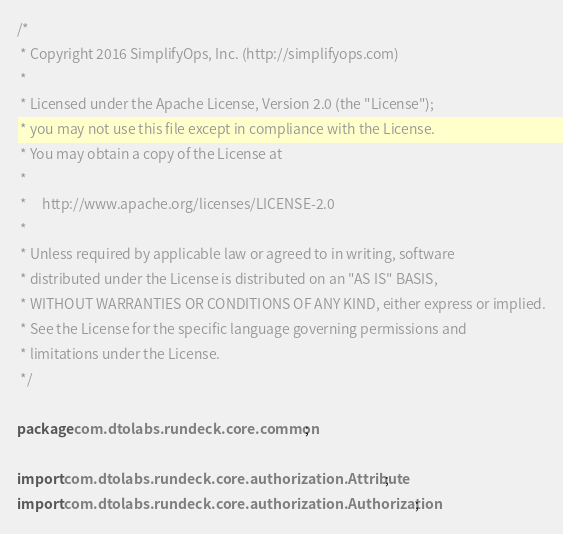Convert code to text. <code><loc_0><loc_0><loc_500><loc_500><_Java_>/*
 * Copyright 2016 SimplifyOps, Inc. (http://simplifyops.com)
 *
 * Licensed under the Apache License, Version 2.0 (the "License");
 * you may not use this file except in compliance with the License.
 * You may obtain a copy of the License at
 *
 *     http://www.apache.org/licenses/LICENSE-2.0
 *
 * Unless required by applicable law or agreed to in writing, software
 * distributed under the License is distributed on an "AS IS" BASIS,
 * WITHOUT WARRANTIES OR CONDITIONS OF ANY KIND, either express or implied.
 * See the License for the specific language governing permissions and
 * limitations under the License.
 */

package com.dtolabs.rundeck.core.common;

import com.dtolabs.rundeck.core.authorization.Attribute;
import com.dtolabs.rundeck.core.authorization.Authorization;</code> 